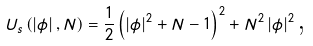<formula> <loc_0><loc_0><loc_500><loc_500>U _ { s } \left ( \left | \phi \right | , N \right ) = \frac { 1 } { 2 } \left ( \left | \phi \right | ^ { 2 } + N - 1 \right ) ^ { 2 } + N ^ { 2 } \left | \phi \right | ^ { 2 } \text {,}</formula> 